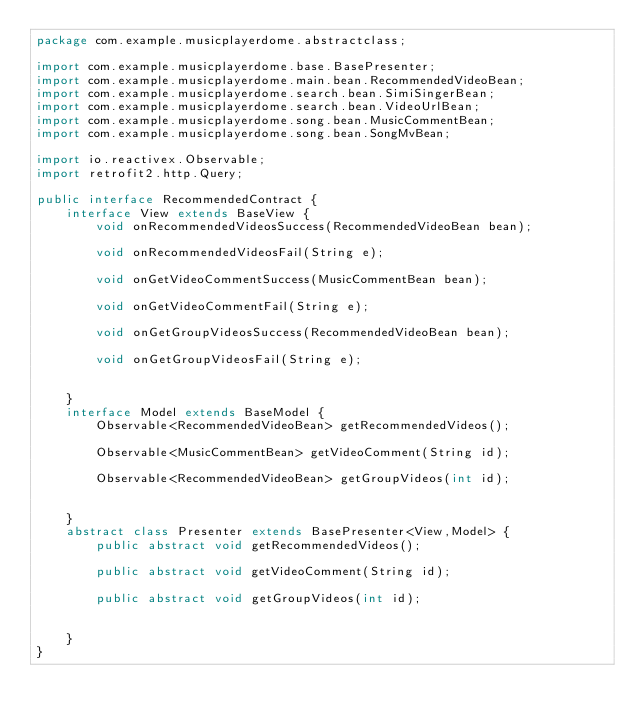<code> <loc_0><loc_0><loc_500><loc_500><_Java_>package com.example.musicplayerdome.abstractclass;

import com.example.musicplayerdome.base.BasePresenter;
import com.example.musicplayerdome.main.bean.RecommendedVideoBean;
import com.example.musicplayerdome.search.bean.SimiSingerBean;
import com.example.musicplayerdome.search.bean.VideoUrlBean;
import com.example.musicplayerdome.song.bean.MusicCommentBean;
import com.example.musicplayerdome.song.bean.SongMvBean;

import io.reactivex.Observable;
import retrofit2.http.Query;

public interface RecommendedContract {
    interface View extends BaseView {
        void onRecommendedVideosSuccess(RecommendedVideoBean bean);

        void onRecommendedVideosFail(String e);

        void onGetVideoCommentSuccess(MusicCommentBean bean);

        void onGetVideoCommentFail(String e);

        void onGetGroupVideosSuccess(RecommendedVideoBean bean);

        void onGetGroupVideosFail(String e);


    }
    interface Model extends BaseModel {
        Observable<RecommendedVideoBean> getRecommendedVideos();

        Observable<MusicCommentBean> getVideoComment(String id);

        Observable<RecommendedVideoBean> getGroupVideos(int id);


    }
    abstract class Presenter extends BasePresenter<View,Model> {
        public abstract void getRecommendedVideos();

        public abstract void getVideoComment(String id);

        public abstract void getGroupVideos(int id);


    }
}
</code> 